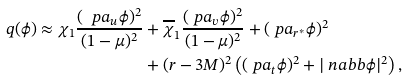Convert formula to latex. <formula><loc_0><loc_0><loc_500><loc_500>q ( \phi ) \approx \chi _ { 1 } \frac { ( \ p a _ { u } \phi ) ^ { 2 } } { ( 1 - \mu ) ^ { 2 } } & + \overline { \chi } _ { 1 } \frac { ( \ p a _ { v } \phi ) ^ { 2 } } { ( 1 - \mu ) ^ { 2 } } + ( \ p a _ { r ^ { * } } \phi ) ^ { 2 } \\ & + ( r - 3 M ) ^ { 2 } \left ( ( \ p a _ { t } \phi ) ^ { 2 } + | \ n a b b \phi | ^ { 2 } \right ) ,</formula> 